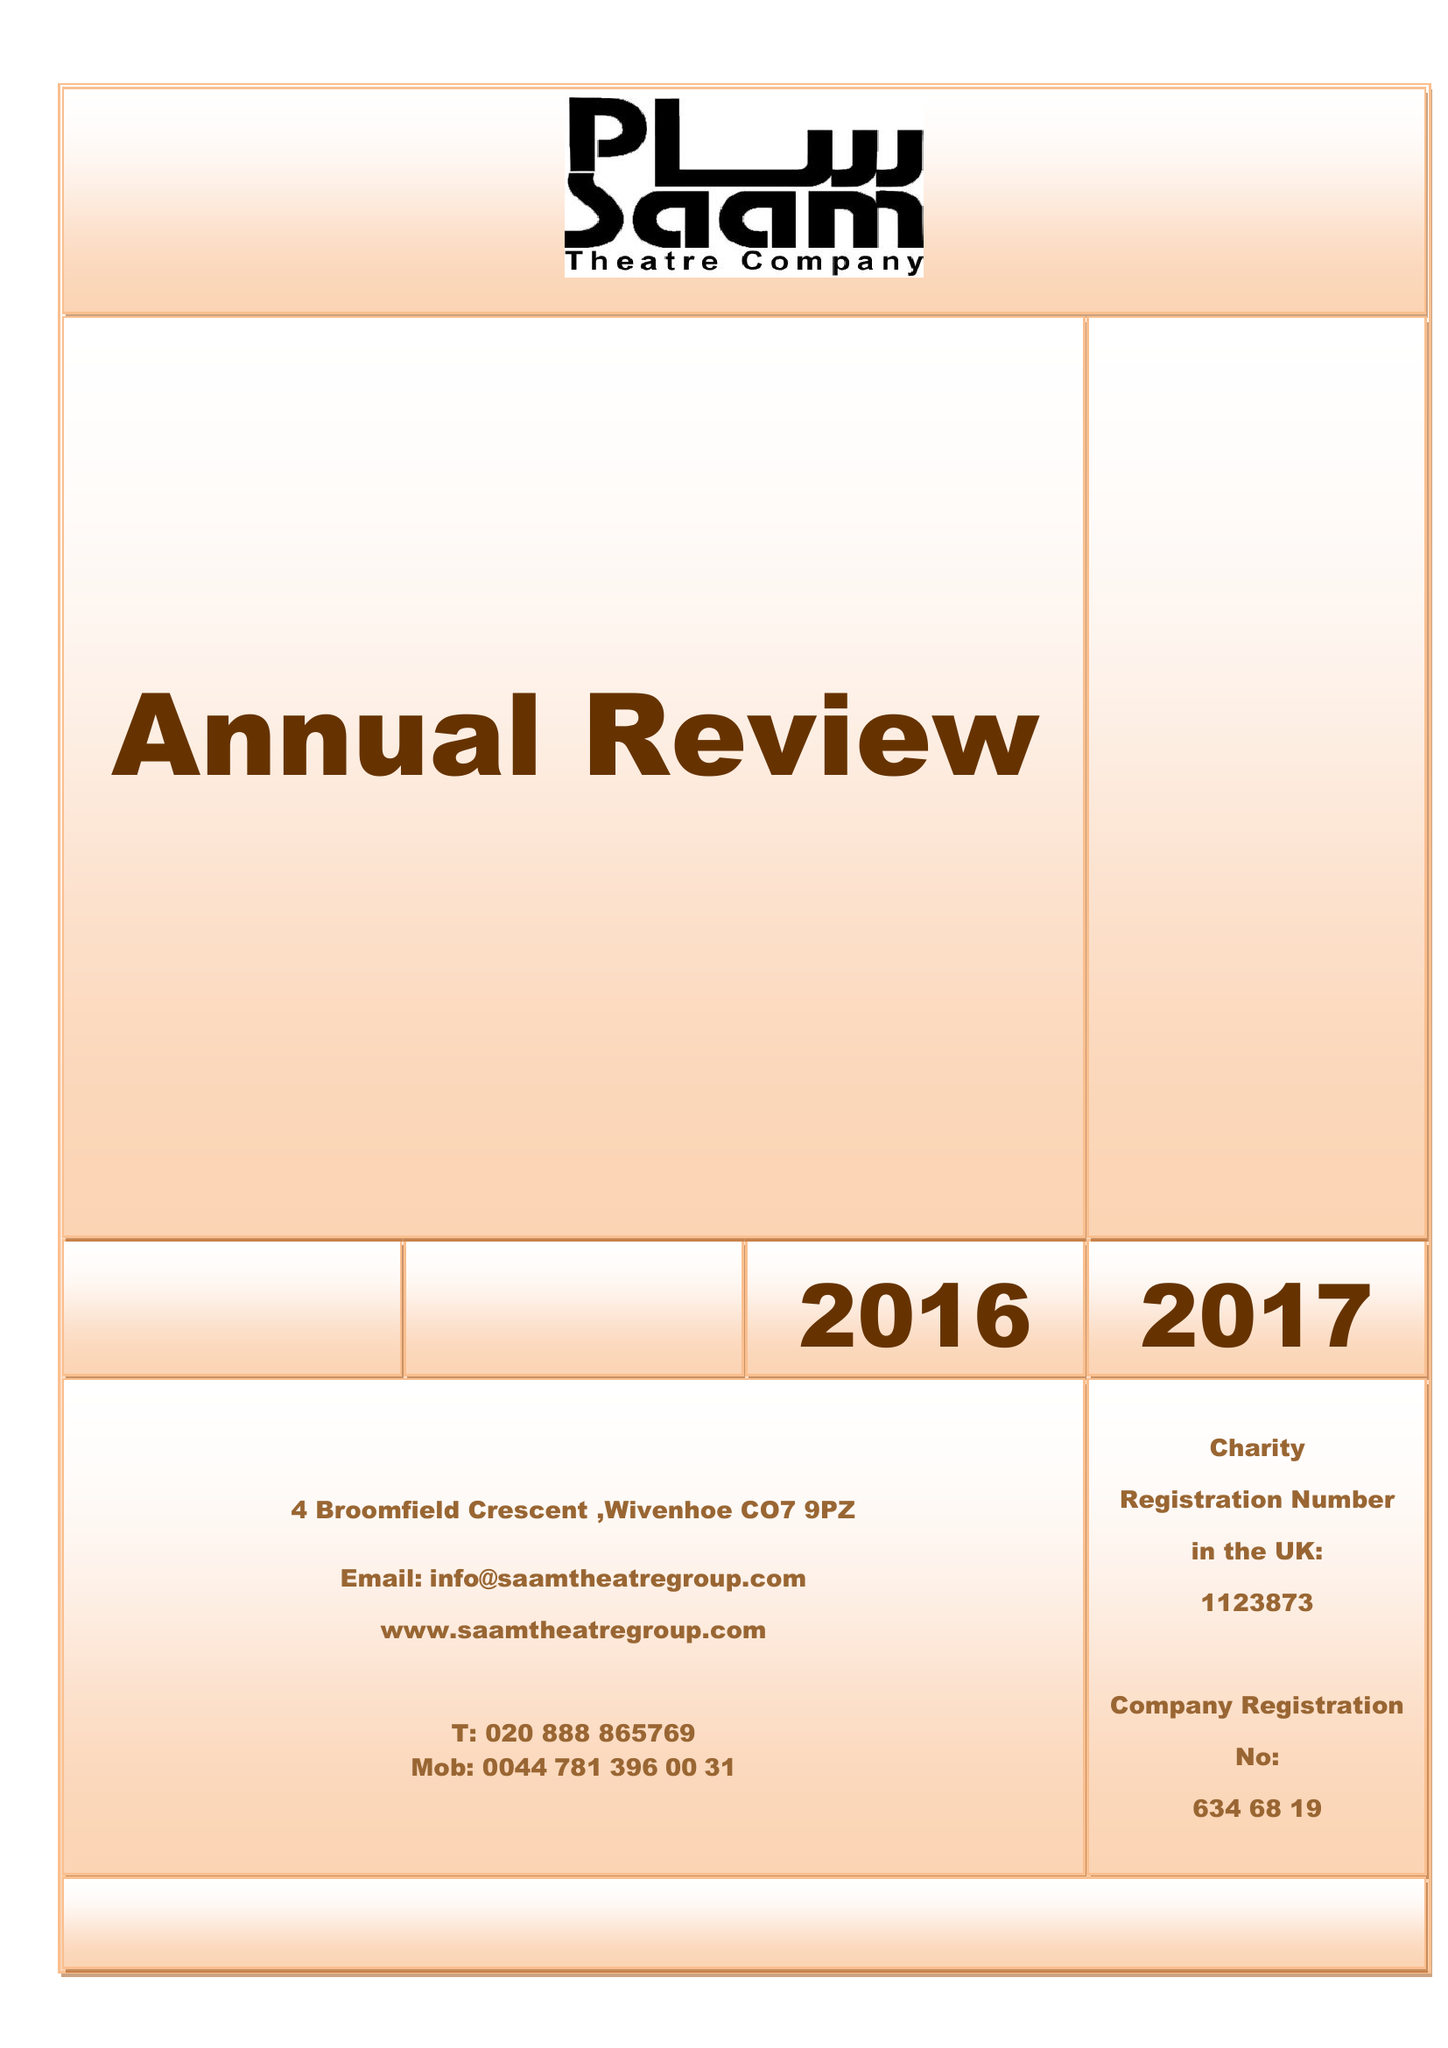What is the value for the income_annually_in_british_pounds?
Answer the question using a single word or phrase. 32000.00 